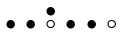Convert formula to latex. <formula><loc_0><loc_0><loc_500><loc_500>\begin{smallmatrix} & & \bullet \\ \bullet & \bullet & \circ & \bullet & \bullet & \circ & \\ \end{smallmatrix}</formula> 